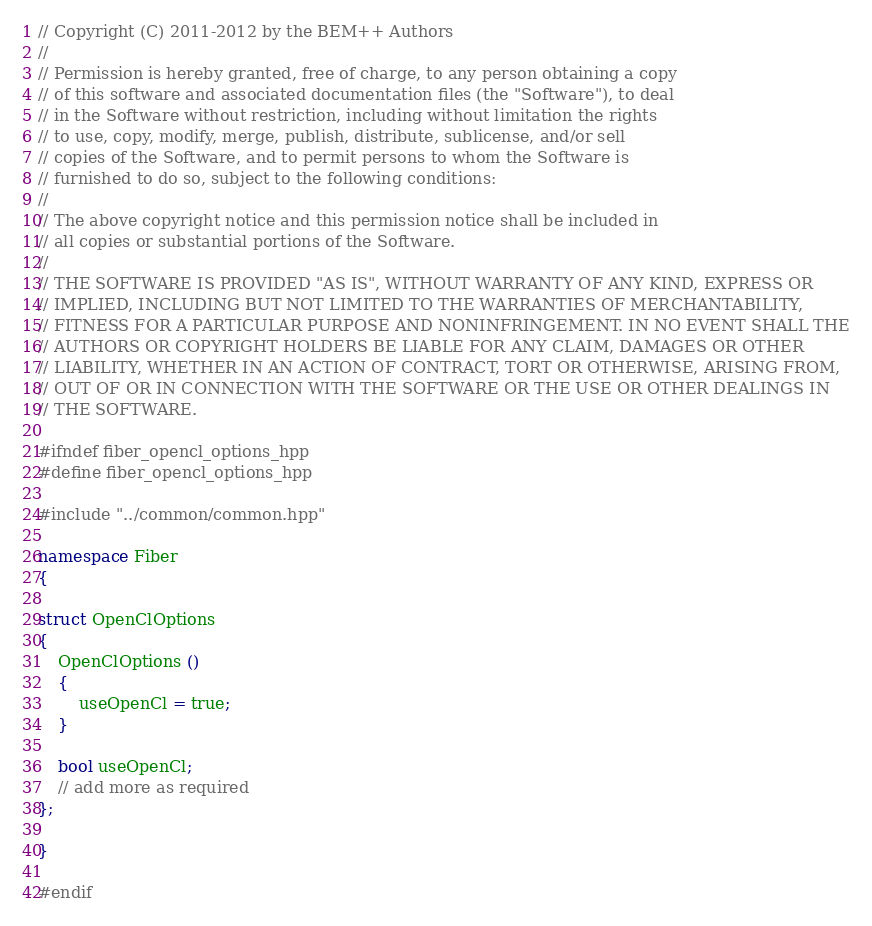<code> <loc_0><loc_0><loc_500><loc_500><_C++_>// Copyright (C) 2011-2012 by the BEM++ Authors
//
// Permission is hereby granted, free of charge, to any person obtaining a copy
// of this software and associated documentation files (the "Software"), to deal
// in the Software without restriction, including without limitation the rights
// to use, copy, modify, merge, publish, distribute, sublicense, and/or sell
// copies of the Software, and to permit persons to whom the Software is
// furnished to do so, subject to the following conditions:
//
// The above copyright notice and this permission notice shall be included in
// all copies or substantial portions of the Software.
//
// THE SOFTWARE IS PROVIDED "AS IS", WITHOUT WARRANTY OF ANY KIND, EXPRESS OR
// IMPLIED, INCLUDING BUT NOT LIMITED TO THE WARRANTIES OF MERCHANTABILITY,
// FITNESS FOR A PARTICULAR PURPOSE AND NONINFRINGEMENT. IN NO EVENT SHALL THE
// AUTHORS OR COPYRIGHT HOLDERS BE LIABLE FOR ANY CLAIM, DAMAGES OR OTHER
// LIABILITY, WHETHER IN AN ACTION OF CONTRACT, TORT OR OTHERWISE, ARISING FROM,
// OUT OF OR IN CONNECTION WITH THE SOFTWARE OR THE USE OR OTHER DEALINGS IN
// THE SOFTWARE.

#ifndef fiber_opencl_options_hpp
#define fiber_opencl_options_hpp

#include "../common/common.hpp"

namespace Fiber
{

struct OpenClOptions
{
    OpenClOptions ()
    {
        useOpenCl = true;
    }

    bool useOpenCl;
    // add more as required
};

}

#endif
</code> 